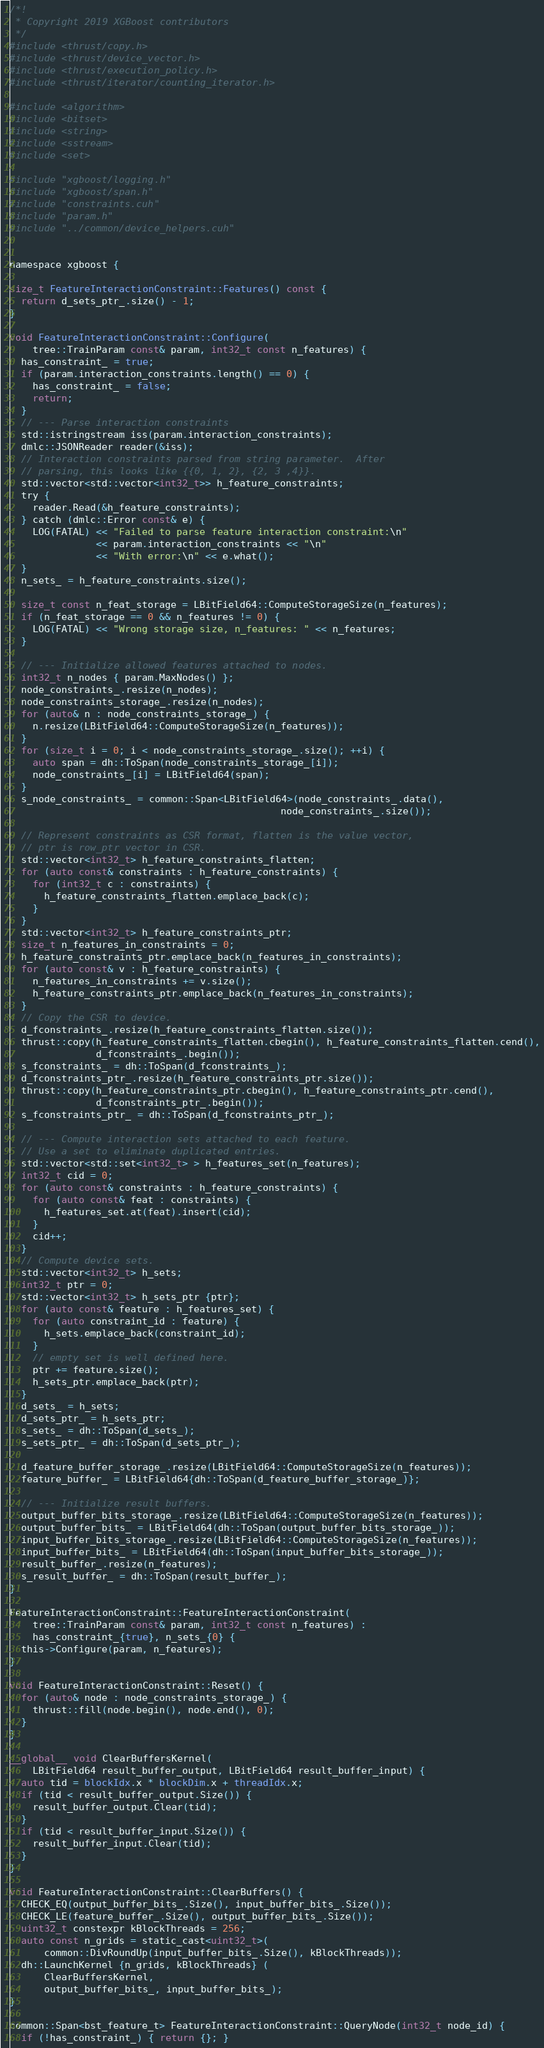<code> <loc_0><loc_0><loc_500><loc_500><_Cuda_>/*!
 * Copyright 2019 XGBoost contributors
 */
#include <thrust/copy.h>
#include <thrust/device_vector.h>
#include <thrust/execution_policy.h>
#include <thrust/iterator/counting_iterator.h>

#include <algorithm>
#include <bitset>
#include <string>
#include <sstream>
#include <set>

#include "xgboost/logging.h"
#include "xgboost/span.h"
#include "constraints.cuh"
#include "param.h"
#include "../common/device_helpers.cuh"


namespace xgboost {

size_t FeatureInteractionConstraint::Features() const {
  return d_sets_ptr_.size() - 1;
}

void FeatureInteractionConstraint::Configure(
    tree::TrainParam const& param, int32_t const n_features) {
  has_constraint_ = true;
  if (param.interaction_constraints.length() == 0) {
    has_constraint_ = false;
    return;
  }
  // --- Parse interaction constraints
  std::istringstream iss(param.interaction_constraints);
  dmlc::JSONReader reader(&iss);
  // Interaction constraints parsed from string parameter.  After
  // parsing, this looks like {{0, 1, 2}, {2, 3 ,4}}.
  std::vector<std::vector<int32_t>> h_feature_constraints;
  try {
    reader.Read(&h_feature_constraints);
  } catch (dmlc::Error const& e) {
    LOG(FATAL) << "Failed to parse feature interaction constraint:\n"
               << param.interaction_constraints << "\n"
               << "With error:\n" << e.what();
  }
  n_sets_ = h_feature_constraints.size();

  size_t const n_feat_storage = LBitField64::ComputeStorageSize(n_features);
  if (n_feat_storage == 0 && n_features != 0) {
    LOG(FATAL) << "Wrong storage size, n_features: " << n_features;
  }

  // --- Initialize allowed features attached to nodes.
  int32_t n_nodes { param.MaxNodes() };
  node_constraints_.resize(n_nodes);
  node_constraints_storage_.resize(n_nodes);
  for (auto& n : node_constraints_storage_) {
    n.resize(LBitField64::ComputeStorageSize(n_features));
  }
  for (size_t i = 0; i < node_constraints_storage_.size(); ++i) {
    auto span = dh::ToSpan(node_constraints_storage_[i]);
    node_constraints_[i] = LBitField64(span);
  }
  s_node_constraints_ = common::Span<LBitField64>(node_constraints_.data(),
                                               node_constraints_.size());

  // Represent constraints as CSR format, flatten is the value vector,
  // ptr is row_ptr vector in CSR.
  std::vector<int32_t> h_feature_constraints_flatten;
  for (auto const& constraints : h_feature_constraints) {
    for (int32_t c : constraints) {
      h_feature_constraints_flatten.emplace_back(c);
    }
  }
  std::vector<int32_t> h_feature_constraints_ptr;
  size_t n_features_in_constraints = 0;
  h_feature_constraints_ptr.emplace_back(n_features_in_constraints);
  for (auto const& v : h_feature_constraints) {
    n_features_in_constraints += v.size();
    h_feature_constraints_ptr.emplace_back(n_features_in_constraints);
  }
  // Copy the CSR to device.
  d_fconstraints_.resize(h_feature_constraints_flatten.size());
  thrust::copy(h_feature_constraints_flatten.cbegin(), h_feature_constraints_flatten.cend(),
               d_fconstraints_.begin());
  s_fconstraints_ = dh::ToSpan(d_fconstraints_);
  d_fconstraints_ptr_.resize(h_feature_constraints_ptr.size());
  thrust::copy(h_feature_constraints_ptr.cbegin(), h_feature_constraints_ptr.cend(),
               d_fconstraints_ptr_.begin());
  s_fconstraints_ptr_ = dh::ToSpan(d_fconstraints_ptr_);

  // --- Compute interaction sets attached to each feature.
  // Use a set to eliminate duplicated entries.
  std::vector<std::set<int32_t> > h_features_set(n_features);
  int32_t cid = 0;
  for (auto const& constraints : h_feature_constraints) {
    for (auto const& feat : constraints) {
      h_features_set.at(feat).insert(cid);
    }
    cid++;
  }
  // Compute device sets.
  std::vector<int32_t> h_sets;
  int32_t ptr = 0;
  std::vector<int32_t> h_sets_ptr {ptr};
  for (auto const& feature : h_features_set) {
    for (auto constraint_id : feature) {
      h_sets.emplace_back(constraint_id);
    }
    // empty set is well defined here.
    ptr += feature.size();
    h_sets_ptr.emplace_back(ptr);
  }
  d_sets_ = h_sets;
  d_sets_ptr_ = h_sets_ptr;
  s_sets_ = dh::ToSpan(d_sets_);
  s_sets_ptr_ = dh::ToSpan(d_sets_ptr_);

  d_feature_buffer_storage_.resize(LBitField64::ComputeStorageSize(n_features));
  feature_buffer_ = LBitField64{dh::ToSpan(d_feature_buffer_storage_)};

  // --- Initialize result buffers.
  output_buffer_bits_storage_.resize(LBitField64::ComputeStorageSize(n_features));
  output_buffer_bits_ = LBitField64(dh::ToSpan(output_buffer_bits_storage_));
  input_buffer_bits_storage_.resize(LBitField64::ComputeStorageSize(n_features));
  input_buffer_bits_ = LBitField64(dh::ToSpan(input_buffer_bits_storage_));
  result_buffer_.resize(n_features);
  s_result_buffer_ = dh::ToSpan(result_buffer_);
}

FeatureInteractionConstraint::FeatureInteractionConstraint(
    tree::TrainParam const& param, int32_t const n_features) :
    has_constraint_{true}, n_sets_{0} {
  this->Configure(param, n_features);
}

void FeatureInteractionConstraint::Reset() {
  for (auto& node : node_constraints_storage_) {
    thrust::fill(node.begin(), node.end(), 0);
  }
}

__global__ void ClearBuffersKernel(
    LBitField64 result_buffer_output, LBitField64 result_buffer_input) {
  auto tid = blockIdx.x * blockDim.x + threadIdx.x;
  if (tid < result_buffer_output.Size()) {
    result_buffer_output.Clear(tid);
  }
  if (tid < result_buffer_input.Size()) {
    result_buffer_input.Clear(tid);
  }
}

void FeatureInteractionConstraint::ClearBuffers() {
  CHECK_EQ(output_buffer_bits_.Size(), input_buffer_bits_.Size());
  CHECK_LE(feature_buffer_.Size(), output_buffer_bits_.Size());
  uint32_t constexpr kBlockThreads = 256;
  auto const n_grids = static_cast<uint32_t>(
      common::DivRoundUp(input_buffer_bits_.Size(), kBlockThreads));
  dh::LaunchKernel {n_grids, kBlockThreads} (
      ClearBuffersKernel,
      output_buffer_bits_, input_buffer_bits_);
}

common::Span<bst_feature_t> FeatureInteractionConstraint::QueryNode(int32_t node_id) {
  if (!has_constraint_) { return {}; }</code> 